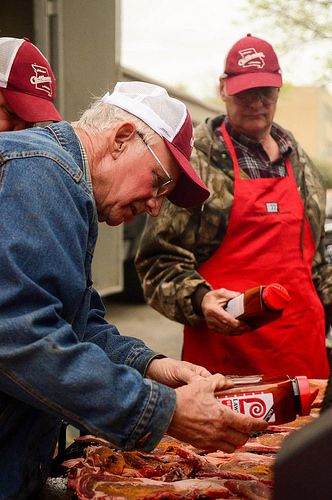<image>
Is there a hat on the man? No. The hat is not positioned on the man. They may be near each other, but the hat is not supported by or resting on top of the man. 